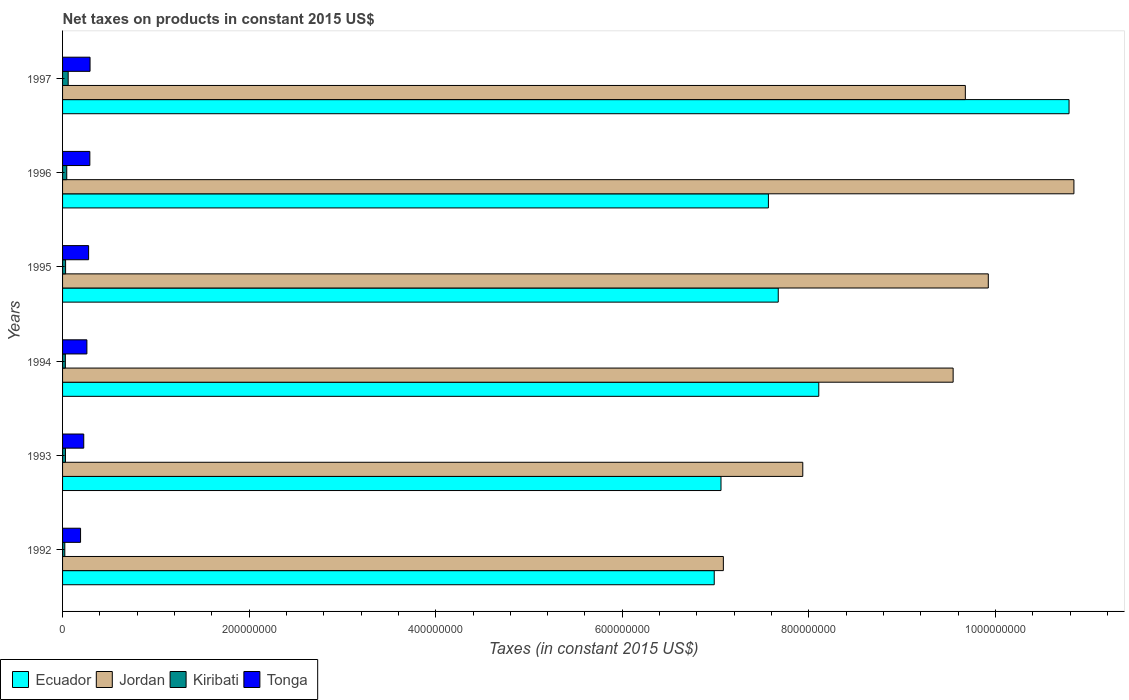How many different coloured bars are there?
Your answer should be compact. 4. Are the number of bars per tick equal to the number of legend labels?
Give a very brief answer. Yes. Are the number of bars on each tick of the Y-axis equal?
Offer a terse response. Yes. How many bars are there on the 6th tick from the top?
Make the answer very short. 4. What is the label of the 2nd group of bars from the top?
Give a very brief answer. 1996. In how many cases, is the number of bars for a given year not equal to the number of legend labels?
Make the answer very short. 0. What is the net taxes on products in Kiribati in 1996?
Provide a succinct answer. 4.49e+06. Across all years, what is the maximum net taxes on products in Tonga?
Keep it short and to the point. 2.95e+07. Across all years, what is the minimum net taxes on products in Kiribati?
Provide a short and direct response. 2.41e+06. In which year was the net taxes on products in Jordan maximum?
Your response must be concise. 1996. What is the total net taxes on products in Jordan in the graph?
Provide a short and direct response. 5.50e+09. What is the difference between the net taxes on products in Jordan in 1994 and that in 1995?
Your response must be concise. -3.77e+07. What is the difference between the net taxes on products in Jordan in 1996 and the net taxes on products in Ecuador in 1997?
Keep it short and to the point. 5.23e+06. What is the average net taxes on products in Jordan per year?
Provide a short and direct response. 9.17e+08. In the year 1995, what is the difference between the net taxes on products in Kiribati and net taxes on products in Jordan?
Make the answer very short. -9.89e+08. What is the ratio of the net taxes on products in Tonga in 1993 to that in 1995?
Your answer should be very brief. 0.81. Is the net taxes on products in Tonga in 1994 less than that in 1995?
Offer a very short reply. Yes. Is the difference between the net taxes on products in Kiribati in 1992 and 1997 greater than the difference between the net taxes on products in Jordan in 1992 and 1997?
Offer a very short reply. Yes. What is the difference between the highest and the second highest net taxes on products in Tonga?
Keep it short and to the point. 2.30e+05. What is the difference between the highest and the lowest net taxes on products in Ecuador?
Offer a very short reply. 3.80e+08. What does the 3rd bar from the top in 1996 represents?
Make the answer very short. Jordan. What does the 4th bar from the bottom in 1992 represents?
Give a very brief answer. Tonga. Is it the case that in every year, the sum of the net taxes on products in Ecuador and net taxes on products in Jordan is greater than the net taxes on products in Tonga?
Offer a terse response. Yes. How many years are there in the graph?
Keep it short and to the point. 6. Where does the legend appear in the graph?
Ensure brevity in your answer.  Bottom left. How many legend labels are there?
Your answer should be very brief. 4. How are the legend labels stacked?
Offer a very short reply. Horizontal. What is the title of the graph?
Your answer should be compact. Net taxes on products in constant 2015 US$. What is the label or title of the X-axis?
Offer a terse response. Taxes (in constant 2015 US$). What is the label or title of the Y-axis?
Ensure brevity in your answer.  Years. What is the Taxes (in constant 2015 US$) of Ecuador in 1992?
Provide a succinct answer. 6.99e+08. What is the Taxes (in constant 2015 US$) in Jordan in 1992?
Your response must be concise. 7.08e+08. What is the Taxes (in constant 2015 US$) of Kiribati in 1992?
Make the answer very short. 2.41e+06. What is the Taxes (in constant 2015 US$) in Tonga in 1992?
Your response must be concise. 1.93e+07. What is the Taxes (in constant 2015 US$) in Ecuador in 1993?
Offer a terse response. 7.06e+08. What is the Taxes (in constant 2015 US$) of Jordan in 1993?
Provide a short and direct response. 7.94e+08. What is the Taxes (in constant 2015 US$) in Kiribati in 1993?
Provide a short and direct response. 3.13e+06. What is the Taxes (in constant 2015 US$) of Tonga in 1993?
Make the answer very short. 2.27e+07. What is the Taxes (in constant 2015 US$) in Ecuador in 1994?
Your answer should be compact. 8.11e+08. What is the Taxes (in constant 2015 US$) in Jordan in 1994?
Your response must be concise. 9.55e+08. What is the Taxes (in constant 2015 US$) of Kiribati in 1994?
Give a very brief answer. 2.99e+06. What is the Taxes (in constant 2015 US$) in Tonga in 1994?
Offer a terse response. 2.61e+07. What is the Taxes (in constant 2015 US$) of Ecuador in 1995?
Provide a succinct answer. 7.67e+08. What is the Taxes (in constant 2015 US$) in Jordan in 1995?
Offer a very short reply. 9.92e+08. What is the Taxes (in constant 2015 US$) in Kiribati in 1995?
Offer a very short reply. 3.25e+06. What is the Taxes (in constant 2015 US$) of Tonga in 1995?
Your answer should be very brief. 2.79e+07. What is the Taxes (in constant 2015 US$) in Ecuador in 1996?
Offer a very short reply. 7.57e+08. What is the Taxes (in constant 2015 US$) of Jordan in 1996?
Ensure brevity in your answer.  1.08e+09. What is the Taxes (in constant 2015 US$) of Kiribati in 1996?
Give a very brief answer. 4.49e+06. What is the Taxes (in constant 2015 US$) in Tonga in 1996?
Offer a terse response. 2.92e+07. What is the Taxes (in constant 2015 US$) of Ecuador in 1997?
Your response must be concise. 1.08e+09. What is the Taxes (in constant 2015 US$) in Jordan in 1997?
Your response must be concise. 9.68e+08. What is the Taxes (in constant 2015 US$) of Kiribati in 1997?
Offer a very short reply. 6.02e+06. What is the Taxes (in constant 2015 US$) of Tonga in 1997?
Your answer should be compact. 2.95e+07. Across all years, what is the maximum Taxes (in constant 2015 US$) of Ecuador?
Keep it short and to the point. 1.08e+09. Across all years, what is the maximum Taxes (in constant 2015 US$) of Jordan?
Ensure brevity in your answer.  1.08e+09. Across all years, what is the maximum Taxes (in constant 2015 US$) in Kiribati?
Your answer should be compact. 6.02e+06. Across all years, what is the maximum Taxes (in constant 2015 US$) in Tonga?
Give a very brief answer. 2.95e+07. Across all years, what is the minimum Taxes (in constant 2015 US$) in Ecuador?
Your answer should be very brief. 6.99e+08. Across all years, what is the minimum Taxes (in constant 2015 US$) in Jordan?
Your response must be concise. 7.08e+08. Across all years, what is the minimum Taxes (in constant 2015 US$) of Kiribati?
Give a very brief answer. 2.41e+06. Across all years, what is the minimum Taxes (in constant 2015 US$) in Tonga?
Your answer should be compact. 1.93e+07. What is the total Taxes (in constant 2015 US$) in Ecuador in the graph?
Provide a succinct answer. 4.82e+09. What is the total Taxes (in constant 2015 US$) in Jordan in the graph?
Your response must be concise. 5.50e+09. What is the total Taxes (in constant 2015 US$) of Kiribati in the graph?
Provide a succinct answer. 2.23e+07. What is the total Taxes (in constant 2015 US$) in Tonga in the graph?
Make the answer very short. 1.55e+08. What is the difference between the Taxes (in constant 2015 US$) in Ecuador in 1992 and that in 1993?
Offer a very short reply. -7.26e+06. What is the difference between the Taxes (in constant 2015 US$) in Jordan in 1992 and that in 1993?
Offer a very short reply. -8.51e+07. What is the difference between the Taxes (in constant 2015 US$) in Kiribati in 1992 and that in 1993?
Keep it short and to the point. -7.22e+05. What is the difference between the Taxes (in constant 2015 US$) in Tonga in 1992 and that in 1993?
Keep it short and to the point. -3.42e+06. What is the difference between the Taxes (in constant 2015 US$) in Ecuador in 1992 and that in 1994?
Your answer should be compact. -1.12e+08. What is the difference between the Taxes (in constant 2015 US$) of Jordan in 1992 and that in 1994?
Provide a succinct answer. -2.46e+08. What is the difference between the Taxes (in constant 2015 US$) in Kiribati in 1992 and that in 1994?
Your response must be concise. -5.78e+05. What is the difference between the Taxes (in constant 2015 US$) of Tonga in 1992 and that in 1994?
Keep it short and to the point. -6.78e+06. What is the difference between the Taxes (in constant 2015 US$) in Ecuador in 1992 and that in 1995?
Offer a terse response. -6.86e+07. What is the difference between the Taxes (in constant 2015 US$) in Jordan in 1992 and that in 1995?
Offer a terse response. -2.84e+08. What is the difference between the Taxes (in constant 2015 US$) of Kiribati in 1992 and that in 1995?
Your answer should be very brief. -8.35e+05. What is the difference between the Taxes (in constant 2015 US$) in Tonga in 1992 and that in 1995?
Offer a very short reply. -8.63e+06. What is the difference between the Taxes (in constant 2015 US$) of Ecuador in 1992 and that in 1996?
Your answer should be compact. -5.81e+07. What is the difference between the Taxes (in constant 2015 US$) of Jordan in 1992 and that in 1996?
Give a very brief answer. -3.76e+08. What is the difference between the Taxes (in constant 2015 US$) in Kiribati in 1992 and that in 1996?
Keep it short and to the point. -2.08e+06. What is the difference between the Taxes (in constant 2015 US$) in Tonga in 1992 and that in 1996?
Ensure brevity in your answer.  -9.94e+06. What is the difference between the Taxes (in constant 2015 US$) of Ecuador in 1992 and that in 1997?
Your answer should be very brief. -3.80e+08. What is the difference between the Taxes (in constant 2015 US$) in Jordan in 1992 and that in 1997?
Your answer should be compact. -2.59e+08. What is the difference between the Taxes (in constant 2015 US$) in Kiribati in 1992 and that in 1997?
Your answer should be very brief. -3.61e+06. What is the difference between the Taxes (in constant 2015 US$) of Tonga in 1992 and that in 1997?
Your answer should be very brief. -1.02e+07. What is the difference between the Taxes (in constant 2015 US$) in Ecuador in 1993 and that in 1994?
Offer a terse response. -1.05e+08. What is the difference between the Taxes (in constant 2015 US$) in Jordan in 1993 and that in 1994?
Keep it short and to the point. -1.61e+08. What is the difference between the Taxes (in constant 2015 US$) in Kiribati in 1993 and that in 1994?
Your response must be concise. 1.43e+05. What is the difference between the Taxes (in constant 2015 US$) of Tonga in 1993 and that in 1994?
Your response must be concise. -3.36e+06. What is the difference between the Taxes (in constant 2015 US$) of Ecuador in 1993 and that in 1995?
Provide a succinct answer. -6.14e+07. What is the difference between the Taxes (in constant 2015 US$) in Jordan in 1993 and that in 1995?
Offer a terse response. -1.99e+08. What is the difference between the Taxes (in constant 2015 US$) of Kiribati in 1993 and that in 1995?
Offer a very short reply. -1.13e+05. What is the difference between the Taxes (in constant 2015 US$) in Tonga in 1993 and that in 1995?
Your answer should be compact. -5.21e+06. What is the difference between the Taxes (in constant 2015 US$) of Ecuador in 1993 and that in 1996?
Offer a very short reply. -5.08e+07. What is the difference between the Taxes (in constant 2015 US$) of Jordan in 1993 and that in 1996?
Your answer should be very brief. -2.91e+08. What is the difference between the Taxes (in constant 2015 US$) in Kiribati in 1993 and that in 1996?
Keep it short and to the point. -1.36e+06. What is the difference between the Taxes (in constant 2015 US$) of Tonga in 1993 and that in 1996?
Give a very brief answer. -6.52e+06. What is the difference between the Taxes (in constant 2015 US$) in Ecuador in 1993 and that in 1997?
Your response must be concise. -3.73e+08. What is the difference between the Taxes (in constant 2015 US$) in Jordan in 1993 and that in 1997?
Provide a succinct answer. -1.74e+08. What is the difference between the Taxes (in constant 2015 US$) of Kiribati in 1993 and that in 1997?
Your answer should be compact. -2.89e+06. What is the difference between the Taxes (in constant 2015 US$) in Tonga in 1993 and that in 1997?
Keep it short and to the point. -6.75e+06. What is the difference between the Taxes (in constant 2015 US$) in Ecuador in 1994 and that in 1995?
Give a very brief answer. 4.34e+07. What is the difference between the Taxes (in constant 2015 US$) of Jordan in 1994 and that in 1995?
Your answer should be very brief. -3.77e+07. What is the difference between the Taxes (in constant 2015 US$) in Kiribati in 1994 and that in 1995?
Keep it short and to the point. -2.57e+05. What is the difference between the Taxes (in constant 2015 US$) of Tonga in 1994 and that in 1995?
Ensure brevity in your answer.  -1.85e+06. What is the difference between the Taxes (in constant 2015 US$) in Ecuador in 1994 and that in 1996?
Keep it short and to the point. 5.40e+07. What is the difference between the Taxes (in constant 2015 US$) of Jordan in 1994 and that in 1996?
Keep it short and to the point. -1.29e+08. What is the difference between the Taxes (in constant 2015 US$) of Kiribati in 1994 and that in 1996?
Keep it short and to the point. -1.50e+06. What is the difference between the Taxes (in constant 2015 US$) of Tonga in 1994 and that in 1996?
Offer a very short reply. -3.16e+06. What is the difference between the Taxes (in constant 2015 US$) in Ecuador in 1994 and that in 1997?
Offer a very short reply. -2.68e+08. What is the difference between the Taxes (in constant 2015 US$) in Jordan in 1994 and that in 1997?
Provide a succinct answer. -1.31e+07. What is the difference between the Taxes (in constant 2015 US$) of Kiribati in 1994 and that in 1997?
Provide a short and direct response. -3.03e+06. What is the difference between the Taxes (in constant 2015 US$) in Tonga in 1994 and that in 1997?
Provide a short and direct response. -3.39e+06. What is the difference between the Taxes (in constant 2015 US$) in Ecuador in 1995 and that in 1996?
Make the answer very short. 1.06e+07. What is the difference between the Taxes (in constant 2015 US$) in Jordan in 1995 and that in 1996?
Your response must be concise. -9.18e+07. What is the difference between the Taxes (in constant 2015 US$) in Kiribati in 1995 and that in 1996?
Your answer should be compact. -1.24e+06. What is the difference between the Taxes (in constant 2015 US$) in Tonga in 1995 and that in 1996?
Provide a succinct answer. -1.31e+06. What is the difference between the Taxes (in constant 2015 US$) of Ecuador in 1995 and that in 1997?
Provide a succinct answer. -3.12e+08. What is the difference between the Taxes (in constant 2015 US$) in Jordan in 1995 and that in 1997?
Give a very brief answer. 2.46e+07. What is the difference between the Taxes (in constant 2015 US$) in Kiribati in 1995 and that in 1997?
Ensure brevity in your answer.  -2.77e+06. What is the difference between the Taxes (in constant 2015 US$) in Tonga in 1995 and that in 1997?
Make the answer very short. -1.54e+06. What is the difference between the Taxes (in constant 2015 US$) of Ecuador in 1996 and that in 1997?
Your response must be concise. -3.22e+08. What is the difference between the Taxes (in constant 2015 US$) of Jordan in 1996 and that in 1997?
Your response must be concise. 1.16e+08. What is the difference between the Taxes (in constant 2015 US$) in Kiribati in 1996 and that in 1997?
Your response must be concise. -1.53e+06. What is the difference between the Taxes (in constant 2015 US$) of Tonga in 1996 and that in 1997?
Your answer should be very brief. -2.30e+05. What is the difference between the Taxes (in constant 2015 US$) of Ecuador in 1992 and the Taxes (in constant 2015 US$) of Jordan in 1993?
Give a very brief answer. -9.49e+07. What is the difference between the Taxes (in constant 2015 US$) of Ecuador in 1992 and the Taxes (in constant 2015 US$) of Kiribati in 1993?
Make the answer very short. 6.95e+08. What is the difference between the Taxes (in constant 2015 US$) in Ecuador in 1992 and the Taxes (in constant 2015 US$) in Tonga in 1993?
Give a very brief answer. 6.76e+08. What is the difference between the Taxes (in constant 2015 US$) of Jordan in 1992 and the Taxes (in constant 2015 US$) of Kiribati in 1993?
Your response must be concise. 7.05e+08. What is the difference between the Taxes (in constant 2015 US$) of Jordan in 1992 and the Taxes (in constant 2015 US$) of Tonga in 1993?
Your answer should be compact. 6.86e+08. What is the difference between the Taxes (in constant 2015 US$) of Kiribati in 1992 and the Taxes (in constant 2015 US$) of Tonga in 1993?
Make the answer very short. -2.03e+07. What is the difference between the Taxes (in constant 2015 US$) in Ecuador in 1992 and the Taxes (in constant 2015 US$) in Jordan in 1994?
Keep it short and to the point. -2.56e+08. What is the difference between the Taxes (in constant 2015 US$) of Ecuador in 1992 and the Taxes (in constant 2015 US$) of Kiribati in 1994?
Your answer should be very brief. 6.96e+08. What is the difference between the Taxes (in constant 2015 US$) in Ecuador in 1992 and the Taxes (in constant 2015 US$) in Tonga in 1994?
Provide a succinct answer. 6.73e+08. What is the difference between the Taxes (in constant 2015 US$) in Jordan in 1992 and the Taxes (in constant 2015 US$) in Kiribati in 1994?
Make the answer very short. 7.05e+08. What is the difference between the Taxes (in constant 2015 US$) of Jordan in 1992 and the Taxes (in constant 2015 US$) of Tonga in 1994?
Provide a succinct answer. 6.82e+08. What is the difference between the Taxes (in constant 2015 US$) of Kiribati in 1992 and the Taxes (in constant 2015 US$) of Tonga in 1994?
Provide a short and direct response. -2.37e+07. What is the difference between the Taxes (in constant 2015 US$) in Ecuador in 1992 and the Taxes (in constant 2015 US$) in Jordan in 1995?
Make the answer very short. -2.94e+08. What is the difference between the Taxes (in constant 2015 US$) of Ecuador in 1992 and the Taxes (in constant 2015 US$) of Kiribati in 1995?
Offer a very short reply. 6.95e+08. What is the difference between the Taxes (in constant 2015 US$) in Ecuador in 1992 and the Taxes (in constant 2015 US$) in Tonga in 1995?
Provide a succinct answer. 6.71e+08. What is the difference between the Taxes (in constant 2015 US$) in Jordan in 1992 and the Taxes (in constant 2015 US$) in Kiribati in 1995?
Your answer should be very brief. 7.05e+08. What is the difference between the Taxes (in constant 2015 US$) of Jordan in 1992 and the Taxes (in constant 2015 US$) of Tonga in 1995?
Ensure brevity in your answer.  6.80e+08. What is the difference between the Taxes (in constant 2015 US$) in Kiribati in 1992 and the Taxes (in constant 2015 US$) in Tonga in 1995?
Your answer should be compact. -2.55e+07. What is the difference between the Taxes (in constant 2015 US$) of Ecuador in 1992 and the Taxes (in constant 2015 US$) of Jordan in 1996?
Your response must be concise. -3.86e+08. What is the difference between the Taxes (in constant 2015 US$) in Ecuador in 1992 and the Taxes (in constant 2015 US$) in Kiribati in 1996?
Your response must be concise. 6.94e+08. What is the difference between the Taxes (in constant 2015 US$) in Ecuador in 1992 and the Taxes (in constant 2015 US$) in Tonga in 1996?
Ensure brevity in your answer.  6.69e+08. What is the difference between the Taxes (in constant 2015 US$) in Jordan in 1992 and the Taxes (in constant 2015 US$) in Kiribati in 1996?
Your response must be concise. 7.04e+08. What is the difference between the Taxes (in constant 2015 US$) of Jordan in 1992 and the Taxes (in constant 2015 US$) of Tonga in 1996?
Keep it short and to the point. 6.79e+08. What is the difference between the Taxes (in constant 2015 US$) of Kiribati in 1992 and the Taxes (in constant 2015 US$) of Tonga in 1996?
Your response must be concise. -2.68e+07. What is the difference between the Taxes (in constant 2015 US$) in Ecuador in 1992 and the Taxes (in constant 2015 US$) in Jordan in 1997?
Provide a short and direct response. -2.69e+08. What is the difference between the Taxes (in constant 2015 US$) of Ecuador in 1992 and the Taxes (in constant 2015 US$) of Kiribati in 1997?
Give a very brief answer. 6.93e+08. What is the difference between the Taxes (in constant 2015 US$) of Ecuador in 1992 and the Taxes (in constant 2015 US$) of Tonga in 1997?
Keep it short and to the point. 6.69e+08. What is the difference between the Taxes (in constant 2015 US$) in Jordan in 1992 and the Taxes (in constant 2015 US$) in Kiribati in 1997?
Make the answer very short. 7.02e+08. What is the difference between the Taxes (in constant 2015 US$) in Jordan in 1992 and the Taxes (in constant 2015 US$) in Tonga in 1997?
Your answer should be compact. 6.79e+08. What is the difference between the Taxes (in constant 2015 US$) of Kiribati in 1992 and the Taxes (in constant 2015 US$) of Tonga in 1997?
Ensure brevity in your answer.  -2.71e+07. What is the difference between the Taxes (in constant 2015 US$) in Ecuador in 1993 and the Taxes (in constant 2015 US$) in Jordan in 1994?
Ensure brevity in your answer.  -2.49e+08. What is the difference between the Taxes (in constant 2015 US$) of Ecuador in 1993 and the Taxes (in constant 2015 US$) of Kiribati in 1994?
Offer a very short reply. 7.03e+08. What is the difference between the Taxes (in constant 2015 US$) in Ecuador in 1993 and the Taxes (in constant 2015 US$) in Tonga in 1994?
Make the answer very short. 6.80e+08. What is the difference between the Taxes (in constant 2015 US$) of Jordan in 1993 and the Taxes (in constant 2015 US$) of Kiribati in 1994?
Your response must be concise. 7.91e+08. What is the difference between the Taxes (in constant 2015 US$) in Jordan in 1993 and the Taxes (in constant 2015 US$) in Tonga in 1994?
Provide a succinct answer. 7.67e+08. What is the difference between the Taxes (in constant 2015 US$) of Kiribati in 1993 and the Taxes (in constant 2015 US$) of Tonga in 1994?
Make the answer very short. -2.29e+07. What is the difference between the Taxes (in constant 2015 US$) in Ecuador in 1993 and the Taxes (in constant 2015 US$) in Jordan in 1995?
Make the answer very short. -2.87e+08. What is the difference between the Taxes (in constant 2015 US$) of Ecuador in 1993 and the Taxes (in constant 2015 US$) of Kiribati in 1995?
Offer a very short reply. 7.03e+08. What is the difference between the Taxes (in constant 2015 US$) of Ecuador in 1993 and the Taxes (in constant 2015 US$) of Tonga in 1995?
Your answer should be compact. 6.78e+08. What is the difference between the Taxes (in constant 2015 US$) of Jordan in 1993 and the Taxes (in constant 2015 US$) of Kiribati in 1995?
Provide a succinct answer. 7.90e+08. What is the difference between the Taxes (in constant 2015 US$) of Jordan in 1993 and the Taxes (in constant 2015 US$) of Tonga in 1995?
Offer a very short reply. 7.66e+08. What is the difference between the Taxes (in constant 2015 US$) of Kiribati in 1993 and the Taxes (in constant 2015 US$) of Tonga in 1995?
Provide a short and direct response. -2.48e+07. What is the difference between the Taxes (in constant 2015 US$) in Ecuador in 1993 and the Taxes (in constant 2015 US$) in Jordan in 1996?
Make the answer very short. -3.78e+08. What is the difference between the Taxes (in constant 2015 US$) in Ecuador in 1993 and the Taxes (in constant 2015 US$) in Kiribati in 1996?
Offer a very short reply. 7.01e+08. What is the difference between the Taxes (in constant 2015 US$) in Ecuador in 1993 and the Taxes (in constant 2015 US$) in Tonga in 1996?
Provide a succinct answer. 6.77e+08. What is the difference between the Taxes (in constant 2015 US$) in Jordan in 1993 and the Taxes (in constant 2015 US$) in Kiribati in 1996?
Offer a terse response. 7.89e+08. What is the difference between the Taxes (in constant 2015 US$) of Jordan in 1993 and the Taxes (in constant 2015 US$) of Tonga in 1996?
Your answer should be compact. 7.64e+08. What is the difference between the Taxes (in constant 2015 US$) of Kiribati in 1993 and the Taxes (in constant 2015 US$) of Tonga in 1996?
Provide a succinct answer. -2.61e+07. What is the difference between the Taxes (in constant 2015 US$) in Ecuador in 1993 and the Taxes (in constant 2015 US$) in Jordan in 1997?
Your response must be concise. -2.62e+08. What is the difference between the Taxes (in constant 2015 US$) in Ecuador in 1993 and the Taxes (in constant 2015 US$) in Kiribati in 1997?
Make the answer very short. 7.00e+08. What is the difference between the Taxes (in constant 2015 US$) in Ecuador in 1993 and the Taxes (in constant 2015 US$) in Tonga in 1997?
Keep it short and to the point. 6.76e+08. What is the difference between the Taxes (in constant 2015 US$) in Jordan in 1993 and the Taxes (in constant 2015 US$) in Kiribati in 1997?
Offer a terse response. 7.88e+08. What is the difference between the Taxes (in constant 2015 US$) in Jordan in 1993 and the Taxes (in constant 2015 US$) in Tonga in 1997?
Give a very brief answer. 7.64e+08. What is the difference between the Taxes (in constant 2015 US$) in Kiribati in 1993 and the Taxes (in constant 2015 US$) in Tonga in 1997?
Offer a terse response. -2.63e+07. What is the difference between the Taxes (in constant 2015 US$) of Ecuador in 1994 and the Taxes (in constant 2015 US$) of Jordan in 1995?
Keep it short and to the point. -1.82e+08. What is the difference between the Taxes (in constant 2015 US$) in Ecuador in 1994 and the Taxes (in constant 2015 US$) in Kiribati in 1995?
Offer a very short reply. 8.07e+08. What is the difference between the Taxes (in constant 2015 US$) in Ecuador in 1994 and the Taxes (in constant 2015 US$) in Tonga in 1995?
Provide a succinct answer. 7.83e+08. What is the difference between the Taxes (in constant 2015 US$) in Jordan in 1994 and the Taxes (in constant 2015 US$) in Kiribati in 1995?
Your answer should be very brief. 9.51e+08. What is the difference between the Taxes (in constant 2015 US$) of Jordan in 1994 and the Taxes (in constant 2015 US$) of Tonga in 1995?
Provide a succinct answer. 9.27e+08. What is the difference between the Taxes (in constant 2015 US$) of Kiribati in 1994 and the Taxes (in constant 2015 US$) of Tonga in 1995?
Keep it short and to the point. -2.49e+07. What is the difference between the Taxes (in constant 2015 US$) in Ecuador in 1994 and the Taxes (in constant 2015 US$) in Jordan in 1996?
Offer a terse response. -2.74e+08. What is the difference between the Taxes (in constant 2015 US$) in Ecuador in 1994 and the Taxes (in constant 2015 US$) in Kiribati in 1996?
Offer a terse response. 8.06e+08. What is the difference between the Taxes (in constant 2015 US$) in Ecuador in 1994 and the Taxes (in constant 2015 US$) in Tonga in 1996?
Offer a terse response. 7.81e+08. What is the difference between the Taxes (in constant 2015 US$) in Jordan in 1994 and the Taxes (in constant 2015 US$) in Kiribati in 1996?
Give a very brief answer. 9.50e+08. What is the difference between the Taxes (in constant 2015 US$) in Jordan in 1994 and the Taxes (in constant 2015 US$) in Tonga in 1996?
Your answer should be very brief. 9.25e+08. What is the difference between the Taxes (in constant 2015 US$) in Kiribati in 1994 and the Taxes (in constant 2015 US$) in Tonga in 1996?
Your answer should be compact. -2.62e+07. What is the difference between the Taxes (in constant 2015 US$) of Ecuador in 1994 and the Taxes (in constant 2015 US$) of Jordan in 1997?
Offer a very short reply. -1.57e+08. What is the difference between the Taxes (in constant 2015 US$) of Ecuador in 1994 and the Taxes (in constant 2015 US$) of Kiribati in 1997?
Your answer should be compact. 8.05e+08. What is the difference between the Taxes (in constant 2015 US$) in Ecuador in 1994 and the Taxes (in constant 2015 US$) in Tonga in 1997?
Keep it short and to the point. 7.81e+08. What is the difference between the Taxes (in constant 2015 US$) of Jordan in 1994 and the Taxes (in constant 2015 US$) of Kiribati in 1997?
Keep it short and to the point. 9.49e+08. What is the difference between the Taxes (in constant 2015 US$) in Jordan in 1994 and the Taxes (in constant 2015 US$) in Tonga in 1997?
Provide a short and direct response. 9.25e+08. What is the difference between the Taxes (in constant 2015 US$) in Kiribati in 1994 and the Taxes (in constant 2015 US$) in Tonga in 1997?
Offer a terse response. -2.65e+07. What is the difference between the Taxes (in constant 2015 US$) of Ecuador in 1995 and the Taxes (in constant 2015 US$) of Jordan in 1996?
Make the answer very short. -3.17e+08. What is the difference between the Taxes (in constant 2015 US$) in Ecuador in 1995 and the Taxes (in constant 2015 US$) in Kiribati in 1996?
Keep it short and to the point. 7.63e+08. What is the difference between the Taxes (in constant 2015 US$) in Ecuador in 1995 and the Taxes (in constant 2015 US$) in Tonga in 1996?
Give a very brief answer. 7.38e+08. What is the difference between the Taxes (in constant 2015 US$) in Jordan in 1995 and the Taxes (in constant 2015 US$) in Kiribati in 1996?
Keep it short and to the point. 9.88e+08. What is the difference between the Taxes (in constant 2015 US$) in Jordan in 1995 and the Taxes (in constant 2015 US$) in Tonga in 1996?
Keep it short and to the point. 9.63e+08. What is the difference between the Taxes (in constant 2015 US$) in Kiribati in 1995 and the Taxes (in constant 2015 US$) in Tonga in 1996?
Give a very brief answer. -2.60e+07. What is the difference between the Taxes (in constant 2015 US$) of Ecuador in 1995 and the Taxes (in constant 2015 US$) of Jordan in 1997?
Provide a succinct answer. -2.01e+08. What is the difference between the Taxes (in constant 2015 US$) in Ecuador in 1995 and the Taxes (in constant 2015 US$) in Kiribati in 1997?
Your response must be concise. 7.61e+08. What is the difference between the Taxes (in constant 2015 US$) in Ecuador in 1995 and the Taxes (in constant 2015 US$) in Tonga in 1997?
Provide a succinct answer. 7.38e+08. What is the difference between the Taxes (in constant 2015 US$) in Jordan in 1995 and the Taxes (in constant 2015 US$) in Kiribati in 1997?
Your response must be concise. 9.86e+08. What is the difference between the Taxes (in constant 2015 US$) of Jordan in 1995 and the Taxes (in constant 2015 US$) of Tonga in 1997?
Provide a succinct answer. 9.63e+08. What is the difference between the Taxes (in constant 2015 US$) of Kiribati in 1995 and the Taxes (in constant 2015 US$) of Tonga in 1997?
Provide a succinct answer. -2.62e+07. What is the difference between the Taxes (in constant 2015 US$) of Ecuador in 1996 and the Taxes (in constant 2015 US$) of Jordan in 1997?
Provide a succinct answer. -2.11e+08. What is the difference between the Taxes (in constant 2015 US$) of Ecuador in 1996 and the Taxes (in constant 2015 US$) of Kiribati in 1997?
Provide a succinct answer. 7.51e+08. What is the difference between the Taxes (in constant 2015 US$) of Ecuador in 1996 and the Taxes (in constant 2015 US$) of Tonga in 1997?
Your answer should be very brief. 7.27e+08. What is the difference between the Taxes (in constant 2015 US$) in Jordan in 1996 and the Taxes (in constant 2015 US$) in Kiribati in 1997?
Ensure brevity in your answer.  1.08e+09. What is the difference between the Taxes (in constant 2015 US$) of Jordan in 1996 and the Taxes (in constant 2015 US$) of Tonga in 1997?
Offer a terse response. 1.05e+09. What is the difference between the Taxes (in constant 2015 US$) in Kiribati in 1996 and the Taxes (in constant 2015 US$) in Tonga in 1997?
Your answer should be very brief. -2.50e+07. What is the average Taxes (in constant 2015 US$) in Ecuador per year?
Offer a terse response. 8.03e+08. What is the average Taxes (in constant 2015 US$) in Jordan per year?
Provide a short and direct response. 9.17e+08. What is the average Taxes (in constant 2015 US$) of Kiribati per year?
Provide a short and direct response. 3.72e+06. What is the average Taxes (in constant 2015 US$) of Tonga per year?
Give a very brief answer. 2.58e+07. In the year 1992, what is the difference between the Taxes (in constant 2015 US$) in Ecuador and Taxes (in constant 2015 US$) in Jordan?
Provide a short and direct response. -9.79e+06. In the year 1992, what is the difference between the Taxes (in constant 2015 US$) in Ecuador and Taxes (in constant 2015 US$) in Kiribati?
Keep it short and to the point. 6.96e+08. In the year 1992, what is the difference between the Taxes (in constant 2015 US$) of Ecuador and Taxes (in constant 2015 US$) of Tonga?
Your answer should be compact. 6.79e+08. In the year 1992, what is the difference between the Taxes (in constant 2015 US$) in Jordan and Taxes (in constant 2015 US$) in Kiribati?
Keep it short and to the point. 7.06e+08. In the year 1992, what is the difference between the Taxes (in constant 2015 US$) of Jordan and Taxes (in constant 2015 US$) of Tonga?
Your response must be concise. 6.89e+08. In the year 1992, what is the difference between the Taxes (in constant 2015 US$) in Kiribati and Taxes (in constant 2015 US$) in Tonga?
Give a very brief answer. -1.69e+07. In the year 1993, what is the difference between the Taxes (in constant 2015 US$) in Ecuador and Taxes (in constant 2015 US$) in Jordan?
Provide a short and direct response. -8.77e+07. In the year 1993, what is the difference between the Taxes (in constant 2015 US$) of Ecuador and Taxes (in constant 2015 US$) of Kiribati?
Your response must be concise. 7.03e+08. In the year 1993, what is the difference between the Taxes (in constant 2015 US$) of Ecuador and Taxes (in constant 2015 US$) of Tonga?
Your answer should be compact. 6.83e+08. In the year 1993, what is the difference between the Taxes (in constant 2015 US$) of Jordan and Taxes (in constant 2015 US$) of Kiribati?
Your answer should be very brief. 7.90e+08. In the year 1993, what is the difference between the Taxes (in constant 2015 US$) of Jordan and Taxes (in constant 2015 US$) of Tonga?
Your response must be concise. 7.71e+08. In the year 1993, what is the difference between the Taxes (in constant 2015 US$) of Kiribati and Taxes (in constant 2015 US$) of Tonga?
Keep it short and to the point. -1.96e+07. In the year 1994, what is the difference between the Taxes (in constant 2015 US$) of Ecuador and Taxes (in constant 2015 US$) of Jordan?
Give a very brief answer. -1.44e+08. In the year 1994, what is the difference between the Taxes (in constant 2015 US$) in Ecuador and Taxes (in constant 2015 US$) in Kiribati?
Your answer should be compact. 8.08e+08. In the year 1994, what is the difference between the Taxes (in constant 2015 US$) of Ecuador and Taxes (in constant 2015 US$) of Tonga?
Ensure brevity in your answer.  7.85e+08. In the year 1994, what is the difference between the Taxes (in constant 2015 US$) in Jordan and Taxes (in constant 2015 US$) in Kiribati?
Offer a terse response. 9.52e+08. In the year 1994, what is the difference between the Taxes (in constant 2015 US$) of Jordan and Taxes (in constant 2015 US$) of Tonga?
Offer a very short reply. 9.29e+08. In the year 1994, what is the difference between the Taxes (in constant 2015 US$) in Kiribati and Taxes (in constant 2015 US$) in Tonga?
Provide a short and direct response. -2.31e+07. In the year 1995, what is the difference between the Taxes (in constant 2015 US$) in Ecuador and Taxes (in constant 2015 US$) in Jordan?
Your response must be concise. -2.25e+08. In the year 1995, what is the difference between the Taxes (in constant 2015 US$) of Ecuador and Taxes (in constant 2015 US$) of Kiribati?
Your answer should be very brief. 7.64e+08. In the year 1995, what is the difference between the Taxes (in constant 2015 US$) in Ecuador and Taxes (in constant 2015 US$) in Tonga?
Offer a very short reply. 7.39e+08. In the year 1995, what is the difference between the Taxes (in constant 2015 US$) in Jordan and Taxes (in constant 2015 US$) in Kiribati?
Your answer should be compact. 9.89e+08. In the year 1995, what is the difference between the Taxes (in constant 2015 US$) of Jordan and Taxes (in constant 2015 US$) of Tonga?
Offer a terse response. 9.64e+08. In the year 1995, what is the difference between the Taxes (in constant 2015 US$) in Kiribati and Taxes (in constant 2015 US$) in Tonga?
Provide a succinct answer. -2.47e+07. In the year 1996, what is the difference between the Taxes (in constant 2015 US$) of Ecuador and Taxes (in constant 2015 US$) of Jordan?
Provide a short and direct response. -3.28e+08. In the year 1996, what is the difference between the Taxes (in constant 2015 US$) of Ecuador and Taxes (in constant 2015 US$) of Kiribati?
Keep it short and to the point. 7.52e+08. In the year 1996, what is the difference between the Taxes (in constant 2015 US$) in Ecuador and Taxes (in constant 2015 US$) in Tonga?
Offer a very short reply. 7.27e+08. In the year 1996, what is the difference between the Taxes (in constant 2015 US$) of Jordan and Taxes (in constant 2015 US$) of Kiribati?
Provide a short and direct response. 1.08e+09. In the year 1996, what is the difference between the Taxes (in constant 2015 US$) of Jordan and Taxes (in constant 2015 US$) of Tonga?
Offer a very short reply. 1.05e+09. In the year 1996, what is the difference between the Taxes (in constant 2015 US$) of Kiribati and Taxes (in constant 2015 US$) of Tonga?
Your answer should be compact. -2.47e+07. In the year 1997, what is the difference between the Taxes (in constant 2015 US$) in Ecuador and Taxes (in constant 2015 US$) in Jordan?
Ensure brevity in your answer.  1.11e+08. In the year 1997, what is the difference between the Taxes (in constant 2015 US$) in Ecuador and Taxes (in constant 2015 US$) in Kiribati?
Keep it short and to the point. 1.07e+09. In the year 1997, what is the difference between the Taxes (in constant 2015 US$) of Ecuador and Taxes (in constant 2015 US$) of Tonga?
Offer a very short reply. 1.05e+09. In the year 1997, what is the difference between the Taxes (in constant 2015 US$) of Jordan and Taxes (in constant 2015 US$) of Kiribati?
Offer a very short reply. 9.62e+08. In the year 1997, what is the difference between the Taxes (in constant 2015 US$) of Jordan and Taxes (in constant 2015 US$) of Tonga?
Give a very brief answer. 9.38e+08. In the year 1997, what is the difference between the Taxes (in constant 2015 US$) in Kiribati and Taxes (in constant 2015 US$) in Tonga?
Give a very brief answer. -2.34e+07. What is the ratio of the Taxes (in constant 2015 US$) in Ecuador in 1992 to that in 1993?
Provide a succinct answer. 0.99. What is the ratio of the Taxes (in constant 2015 US$) of Jordan in 1992 to that in 1993?
Offer a very short reply. 0.89. What is the ratio of the Taxes (in constant 2015 US$) in Kiribati in 1992 to that in 1993?
Make the answer very short. 0.77. What is the ratio of the Taxes (in constant 2015 US$) in Tonga in 1992 to that in 1993?
Give a very brief answer. 0.85. What is the ratio of the Taxes (in constant 2015 US$) in Ecuador in 1992 to that in 1994?
Provide a succinct answer. 0.86. What is the ratio of the Taxes (in constant 2015 US$) in Jordan in 1992 to that in 1994?
Offer a terse response. 0.74. What is the ratio of the Taxes (in constant 2015 US$) of Kiribati in 1992 to that in 1994?
Offer a terse response. 0.81. What is the ratio of the Taxes (in constant 2015 US$) in Tonga in 1992 to that in 1994?
Your answer should be very brief. 0.74. What is the ratio of the Taxes (in constant 2015 US$) of Ecuador in 1992 to that in 1995?
Your answer should be compact. 0.91. What is the ratio of the Taxes (in constant 2015 US$) in Jordan in 1992 to that in 1995?
Your response must be concise. 0.71. What is the ratio of the Taxes (in constant 2015 US$) of Kiribati in 1992 to that in 1995?
Give a very brief answer. 0.74. What is the ratio of the Taxes (in constant 2015 US$) in Tonga in 1992 to that in 1995?
Give a very brief answer. 0.69. What is the ratio of the Taxes (in constant 2015 US$) in Ecuador in 1992 to that in 1996?
Offer a very short reply. 0.92. What is the ratio of the Taxes (in constant 2015 US$) of Jordan in 1992 to that in 1996?
Keep it short and to the point. 0.65. What is the ratio of the Taxes (in constant 2015 US$) in Kiribati in 1992 to that in 1996?
Your answer should be very brief. 0.54. What is the ratio of the Taxes (in constant 2015 US$) in Tonga in 1992 to that in 1996?
Your answer should be very brief. 0.66. What is the ratio of the Taxes (in constant 2015 US$) of Ecuador in 1992 to that in 1997?
Your answer should be compact. 0.65. What is the ratio of the Taxes (in constant 2015 US$) in Jordan in 1992 to that in 1997?
Offer a very short reply. 0.73. What is the ratio of the Taxes (in constant 2015 US$) of Kiribati in 1992 to that in 1997?
Keep it short and to the point. 0.4. What is the ratio of the Taxes (in constant 2015 US$) of Tonga in 1992 to that in 1997?
Provide a succinct answer. 0.65. What is the ratio of the Taxes (in constant 2015 US$) in Ecuador in 1993 to that in 1994?
Ensure brevity in your answer.  0.87. What is the ratio of the Taxes (in constant 2015 US$) in Jordan in 1993 to that in 1994?
Offer a terse response. 0.83. What is the ratio of the Taxes (in constant 2015 US$) in Kiribati in 1993 to that in 1994?
Make the answer very short. 1.05. What is the ratio of the Taxes (in constant 2015 US$) in Tonga in 1993 to that in 1994?
Make the answer very short. 0.87. What is the ratio of the Taxes (in constant 2015 US$) in Jordan in 1993 to that in 1995?
Offer a terse response. 0.8. What is the ratio of the Taxes (in constant 2015 US$) in Kiribati in 1993 to that in 1995?
Provide a short and direct response. 0.97. What is the ratio of the Taxes (in constant 2015 US$) of Tonga in 1993 to that in 1995?
Your response must be concise. 0.81. What is the ratio of the Taxes (in constant 2015 US$) in Ecuador in 1993 to that in 1996?
Offer a terse response. 0.93. What is the ratio of the Taxes (in constant 2015 US$) of Jordan in 1993 to that in 1996?
Provide a short and direct response. 0.73. What is the ratio of the Taxes (in constant 2015 US$) of Kiribati in 1993 to that in 1996?
Your answer should be very brief. 0.7. What is the ratio of the Taxes (in constant 2015 US$) of Tonga in 1993 to that in 1996?
Your answer should be compact. 0.78. What is the ratio of the Taxes (in constant 2015 US$) in Ecuador in 1993 to that in 1997?
Keep it short and to the point. 0.65. What is the ratio of the Taxes (in constant 2015 US$) in Jordan in 1993 to that in 1997?
Provide a succinct answer. 0.82. What is the ratio of the Taxes (in constant 2015 US$) of Kiribati in 1993 to that in 1997?
Provide a short and direct response. 0.52. What is the ratio of the Taxes (in constant 2015 US$) of Tonga in 1993 to that in 1997?
Give a very brief answer. 0.77. What is the ratio of the Taxes (in constant 2015 US$) of Ecuador in 1994 to that in 1995?
Provide a succinct answer. 1.06. What is the ratio of the Taxes (in constant 2015 US$) in Jordan in 1994 to that in 1995?
Provide a succinct answer. 0.96. What is the ratio of the Taxes (in constant 2015 US$) of Kiribati in 1994 to that in 1995?
Make the answer very short. 0.92. What is the ratio of the Taxes (in constant 2015 US$) in Tonga in 1994 to that in 1995?
Offer a very short reply. 0.93. What is the ratio of the Taxes (in constant 2015 US$) of Ecuador in 1994 to that in 1996?
Your answer should be compact. 1.07. What is the ratio of the Taxes (in constant 2015 US$) of Jordan in 1994 to that in 1996?
Make the answer very short. 0.88. What is the ratio of the Taxes (in constant 2015 US$) of Kiribati in 1994 to that in 1996?
Provide a short and direct response. 0.67. What is the ratio of the Taxes (in constant 2015 US$) in Tonga in 1994 to that in 1996?
Offer a very short reply. 0.89. What is the ratio of the Taxes (in constant 2015 US$) in Ecuador in 1994 to that in 1997?
Provide a short and direct response. 0.75. What is the ratio of the Taxes (in constant 2015 US$) of Jordan in 1994 to that in 1997?
Your response must be concise. 0.99. What is the ratio of the Taxes (in constant 2015 US$) of Kiribati in 1994 to that in 1997?
Your answer should be compact. 0.5. What is the ratio of the Taxes (in constant 2015 US$) of Tonga in 1994 to that in 1997?
Your answer should be very brief. 0.89. What is the ratio of the Taxes (in constant 2015 US$) in Ecuador in 1995 to that in 1996?
Your answer should be compact. 1.01. What is the ratio of the Taxes (in constant 2015 US$) of Jordan in 1995 to that in 1996?
Your response must be concise. 0.92. What is the ratio of the Taxes (in constant 2015 US$) in Kiribati in 1995 to that in 1996?
Provide a short and direct response. 0.72. What is the ratio of the Taxes (in constant 2015 US$) of Tonga in 1995 to that in 1996?
Ensure brevity in your answer.  0.96. What is the ratio of the Taxes (in constant 2015 US$) in Ecuador in 1995 to that in 1997?
Offer a terse response. 0.71. What is the ratio of the Taxes (in constant 2015 US$) in Jordan in 1995 to that in 1997?
Your answer should be compact. 1.03. What is the ratio of the Taxes (in constant 2015 US$) of Kiribati in 1995 to that in 1997?
Keep it short and to the point. 0.54. What is the ratio of the Taxes (in constant 2015 US$) of Tonga in 1995 to that in 1997?
Your response must be concise. 0.95. What is the ratio of the Taxes (in constant 2015 US$) of Ecuador in 1996 to that in 1997?
Your response must be concise. 0.7. What is the ratio of the Taxes (in constant 2015 US$) of Jordan in 1996 to that in 1997?
Your response must be concise. 1.12. What is the ratio of the Taxes (in constant 2015 US$) of Kiribati in 1996 to that in 1997?
Provide a succinct answer. 0.75. What is the difference between the highest and the second highest Taxes (in constant 2015 US$) of Ecuador?
Offer a terse response. 2.68e+08. What is the difference between the highest and the second highest Taxes (in constant 2015 US$) in Jordan?
Your answer should be very brief. 9.18e+07. What is the difference between the highest and the second highest Taxes (in constant 2015 US$) in Kiribati?
Give a very brief answer. 1.53e+06. What is the difference between the highest and the second highest Taxes (in constant 2015 US$) of Tonga?
Provide a short and direct response. 2.30e+05. What is the difference between the highest and the lowest Taxes (in constant 2015 US$) in Ecuador?
Your answer should be compact. 3.80e+08. What is the difference between the highest and the lowest Taxes (in constant 2015 US$) in Jordan?
Keep it short and to the point. 3.76e+08. What is the difference between the highest and the lowest Taxes (in constant 2015 US$) of Kiribati?
Ensure brevity in your answer.  3.61e+06. What is the difference between the highest and the lowest Taxes (in constant 2015 US$) in Tonga?
Make the answer very short. 1.02e+07. 